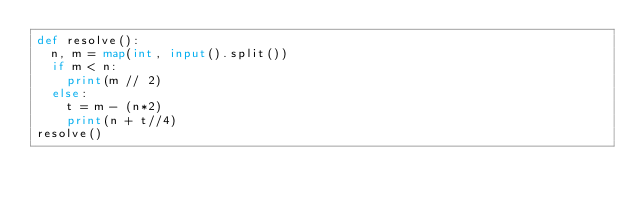<code> <loc_0><loc_0><loc_500><loc_500><_Python_>def resolve():
	n, m = map(int, input().split())
	if m < n:
		print(m // 2)
	else:
		t = m - (n*2)
		print(n + t//4)
resolve()</code> 